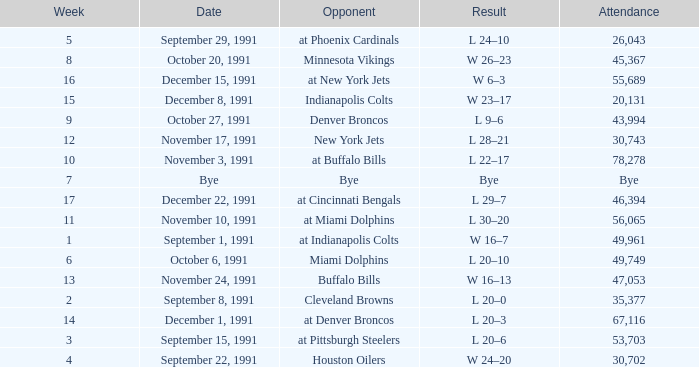What was the result of the game after Week 13 on December 8, 1991? W 23–17. 